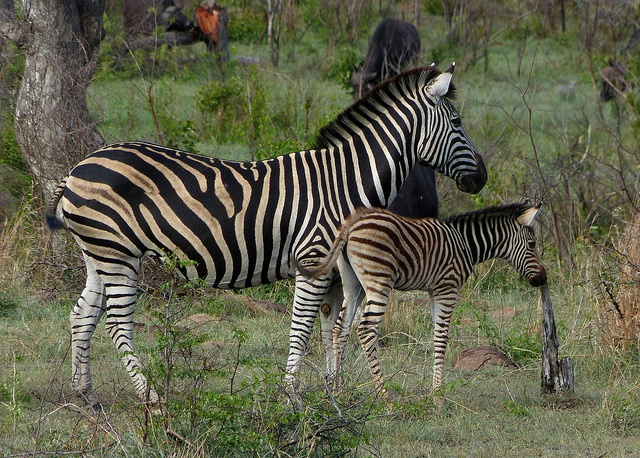Describe the objects in this image and their specific colors. I can see zebra in gray, black, darkgray, and tan tones and zebra in gray, black, and darkgray tones in this image. 